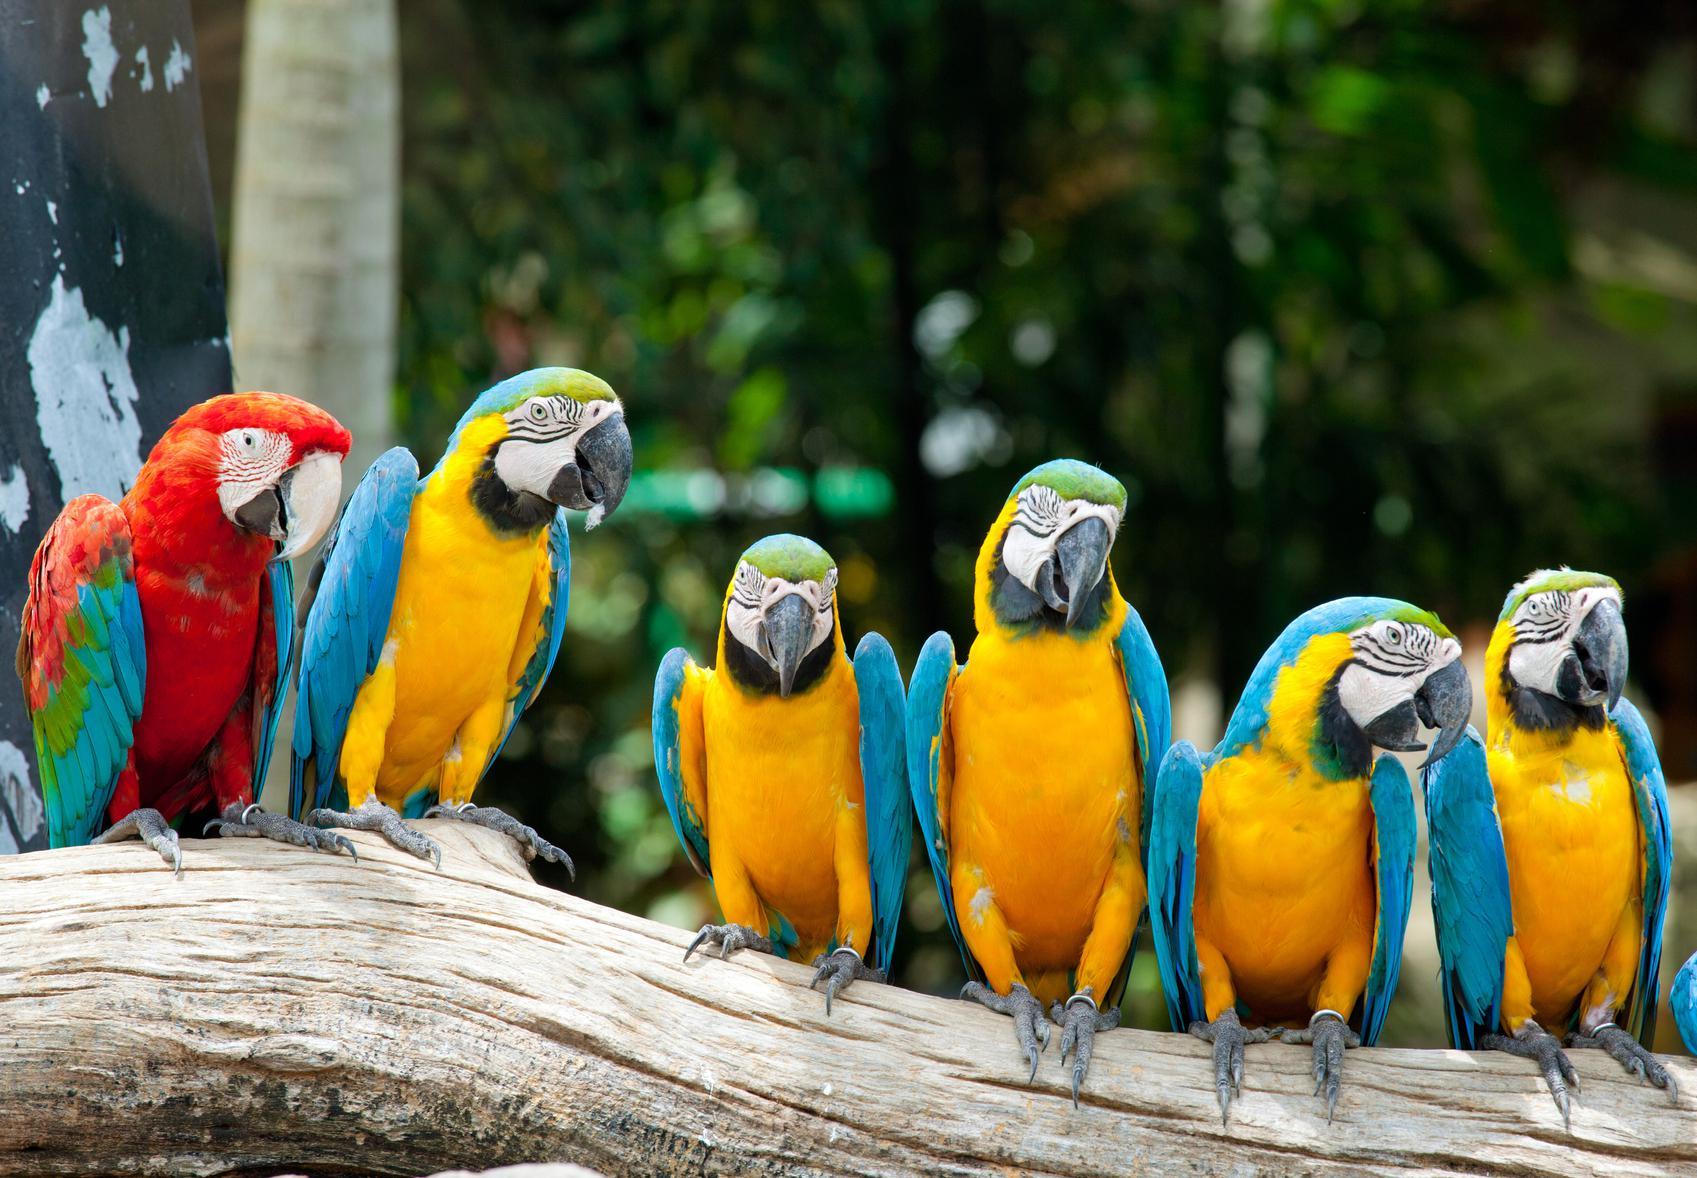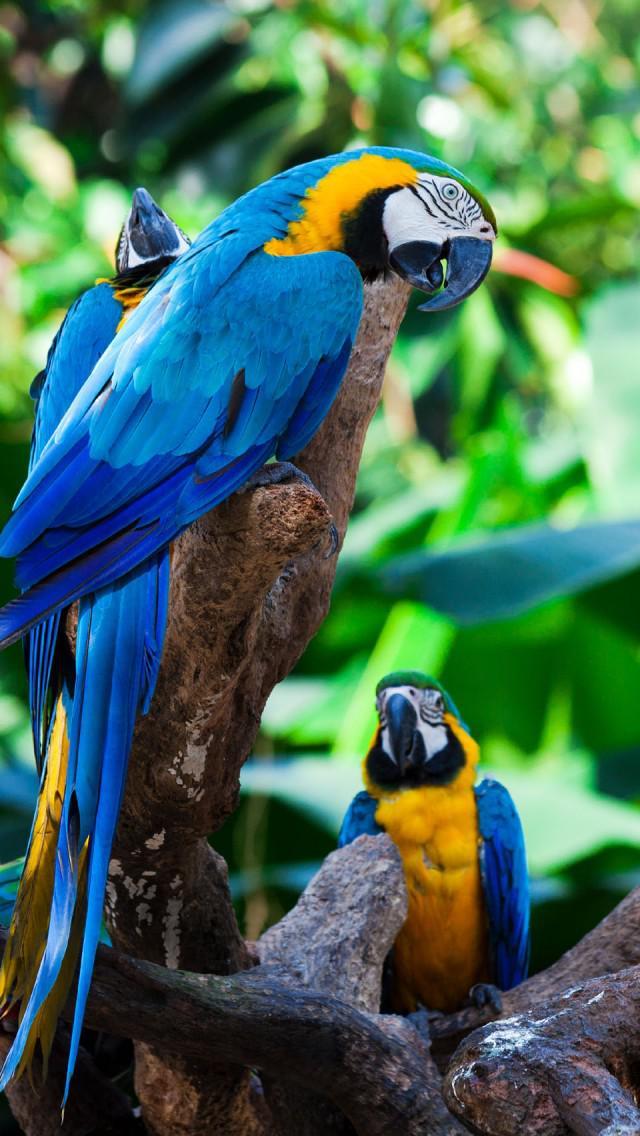The first image is the image on the left, the second image is the image on the right. Examine the images to the left and right. Is the description "There are at least four birds in the image on the right." accurate? Answer yes or no. No. 